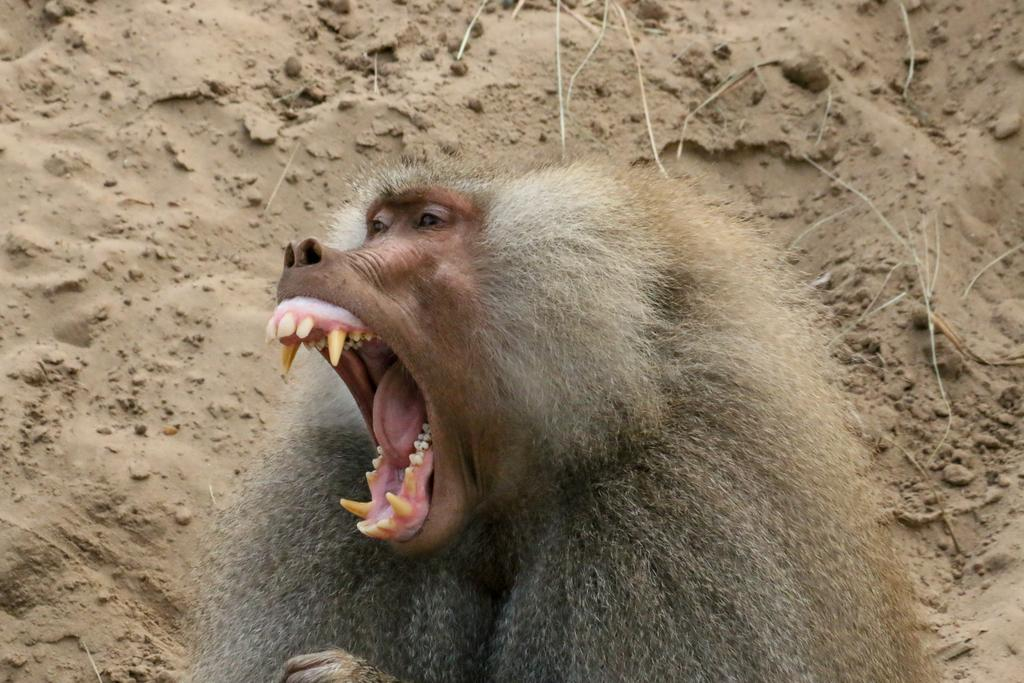What type of animal can be seen in the image? There is an animal in the image that resembles a monkey. What might the animal be doing in the image? The animal might be screaming or yawning. What can be seen in the background of the image? There is soil visible in the background of the image. What is the color of the soil? The soil is brown in color. What type of spoon can be seen in the animal's hand in the image? There is no spoon present in the image; the animal is not holding anything. What type of taste can be experienced from the animal's expression in the image? There is no taste associated with the animal's expression in the image, as it is a visual representation and not a sensory experience. 